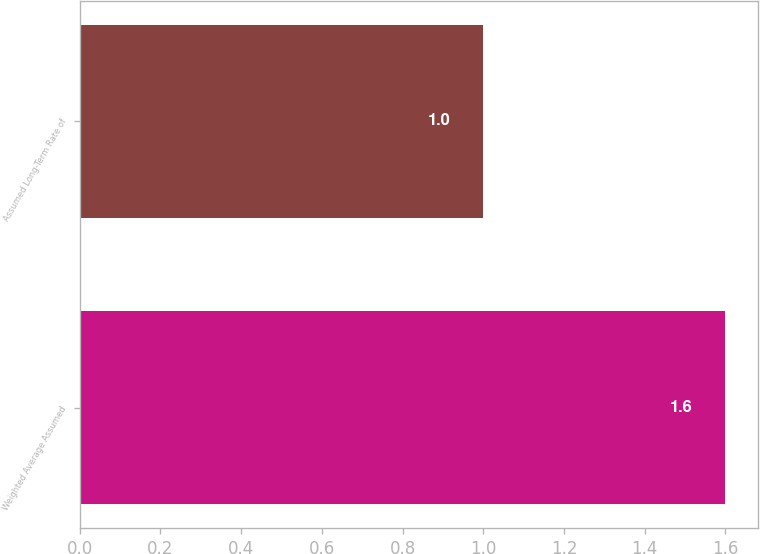Convert chart to OTSL. <chart><loc_0><loc_0><loc_500><loc_500><bar_chart><fcel>Weighted Average Assumed<fcel>Assumed Long-Term Rate of<nl><fcel>1.6<fcel>1<nl></chart> 